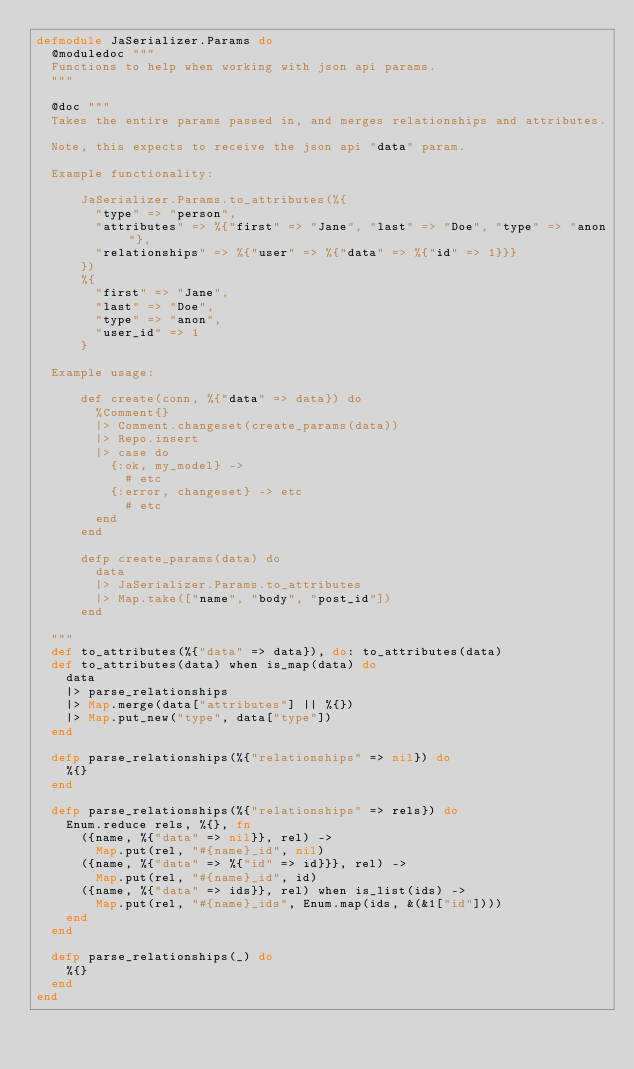<code> <loc_0><loc_0><loc_500><loc_500><_Elixir_>defmodule JaSerializer.Params do
  @moduledoc """
  Functions to help when working with json api params.
  """

  @doc """
  Takes the entire params passed in, and merges relationships and attributes.

  Note, this expects to receive the json api "data" param.

  Example functionality:

      JaSerializer.Params.to_attributes(%{
        "type" => "person",
        "attributes" => %{"first" => "Jane", "last" => "Doe", "type" => "anon"},
        "relationships" => %{"user" => %{"data" => %{"id" => 1}}}
      })
      %{
        "first" => "Jane",
        "last" => "Doe",
        "type" => "anon",
        "user_id" => 1
      }

  Example usage:

      def create(conn, %{"data" => data}) do
        %Comment{}
        |> Comment.changeset(create_params(data))
        |> Repo.insert
        |> case do
          {:ok, my_model} ->
            # etc
          {:error, changeset} -> etc
            # etc
        end
      end

      defp create_params(data) do
        data
        |> JaSerializer.Params.to_attributes
        |> Map.take(["name", "body", "post_id"])
      end

  """
  def to_attributes(%{"data" => data}), do: to_attributes(data)
  def to_attributes(data) when is_map(data) do
    data
    |> parse_relationships
    |> Map.merge(data["attributes"] || %{})
    |> Map.put_new("type", data["type"])
  end

  defp parse_relationships(%{"relationships" => nil}) do
    %{}
  end

  defp parse_relationships(%{"relationships" => rels}) do
    Enum.reduce rels, %{}, fn
      ({name, %{"data" => nil}}, rel) ->
        Map.put(rel, "#{name}_id", nil)
      ({name, %{"data" => %{"id" => id}}}, rel) ->
        Map.put(rel, "#{name}_id", id)
      ({name, %{"data" => ids}}, rel) when is_list(ids) ->
        Map.put(rel, "#{name}_ids", Enum.map(ids, &(&1["id"])))
    end
  end

  defp parse_relationships(_) do
    %{}
  end
end
</code> 